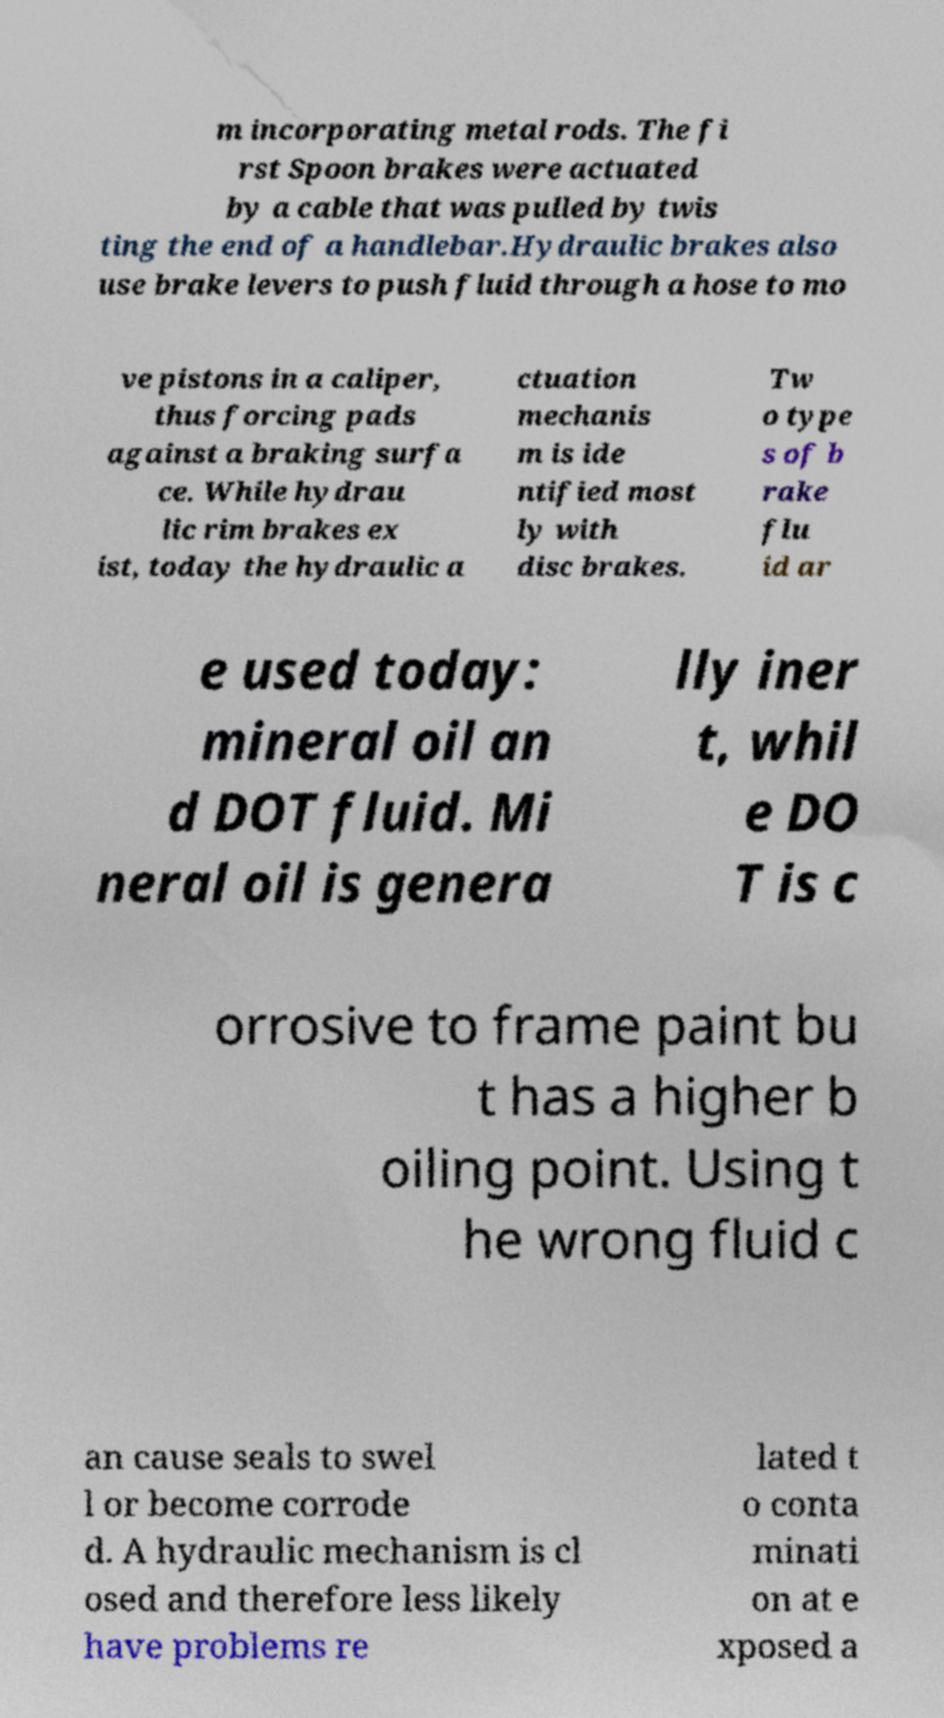For documentation purposes, I need the text within this image transcribed. Could you provide that? m incorporating metal rods. The fi rst Spoon brakes were actuated by a cable that was pulled by twis ting the end of a handlebar.Hydraulic brakes also use brake levers to push fluid through a hose to mo ve pistons in a caliper, thus forcing pads against a braking surfa ce. While hydrau lic rim brakes ex ist, today the hydraulic a ctuation mechanis m is ide ntified most ly with disc brakes. Tw o type s of b rake flu id ar e used today: mineral oil an d DOT fluid. Mi neral oil is genera lly iner t, whil e DO T is c orrosive to frame paint bu t has a higher b oiling point. Using t he wrong fluid c an cause seals to swel l or become corrode d. A hydraulic mechanism is cl osed and therefore less likely have problems re lated t o conta minati on at e xposed a 